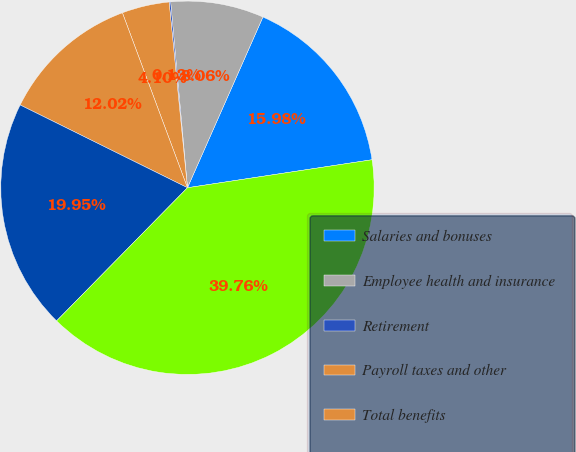Convert chart to OTSL. <chart><loc_0><loc_0><loc_500><loc_500><pie_chart><fcel>Salaries and bonuses<fcel>Employee health and insurance<fcel>Retirement<fcel>Payroll taxes and other<fcel>Total benefits<fcel>Total salaries and employee<fcel>Full-time equivalent employees<nl><fcel>15.98%<fcel>8.06%<fcel>0.13%<fcel>4.1%<fcel>12.02%<fcel>19.95%<fcel>39.76%<nl></chart> 